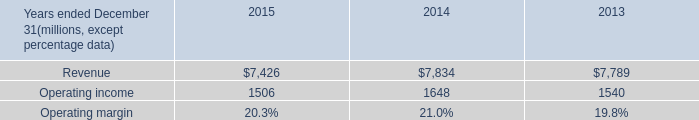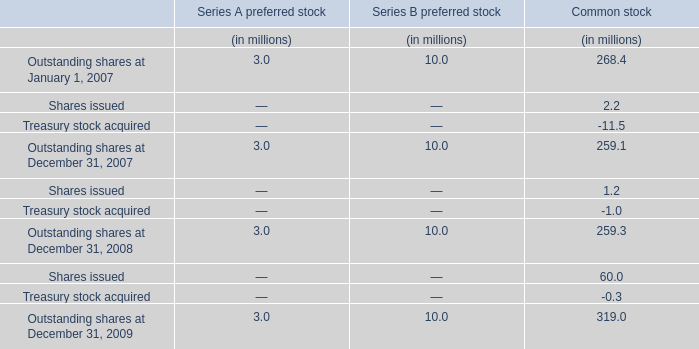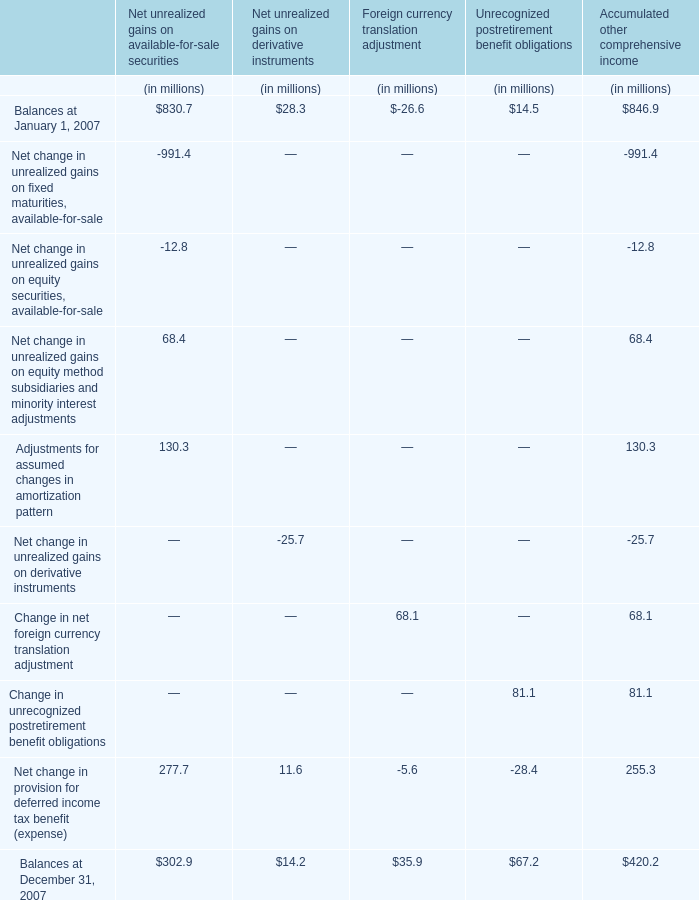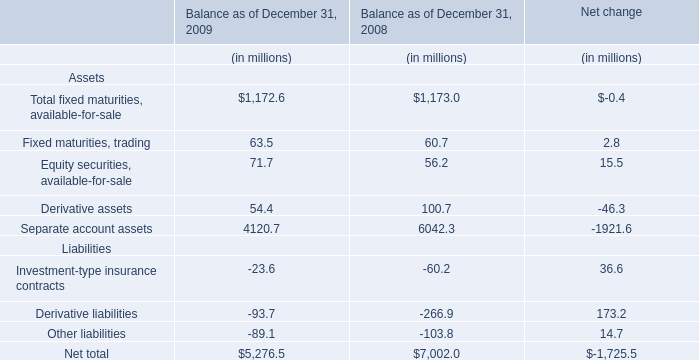what is the net income margin for 2015? 
Computations: ((1.4 * 1000) / 7426)
Answer: 0.18853. 